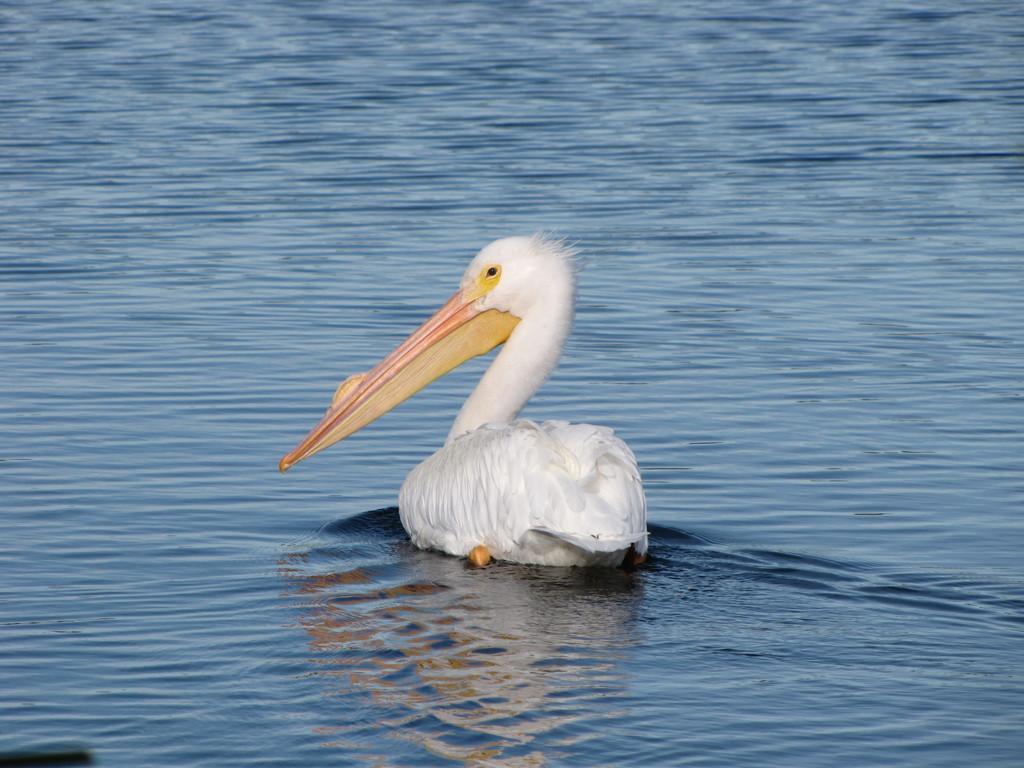Describe this image in one or two sentences. We can see a bird is on the water. 